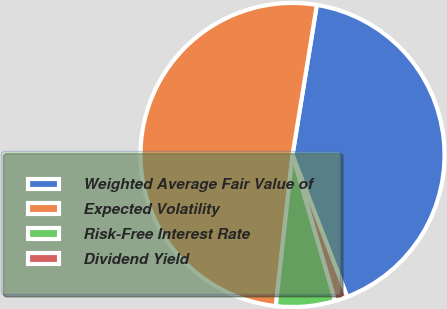<chart> <loc_0><loc_0><loc_500><loc_500><pie_chart><fcel>Weighted Average Fair Value of<fcel>Expected Volatility<fcel>Risk-Free Interest Rate<fcel>Dividend Yield<nl><fcel>41.59%<fcel>50.81%<fcel>6.28%<fcel>1.33%<nl></chart> 